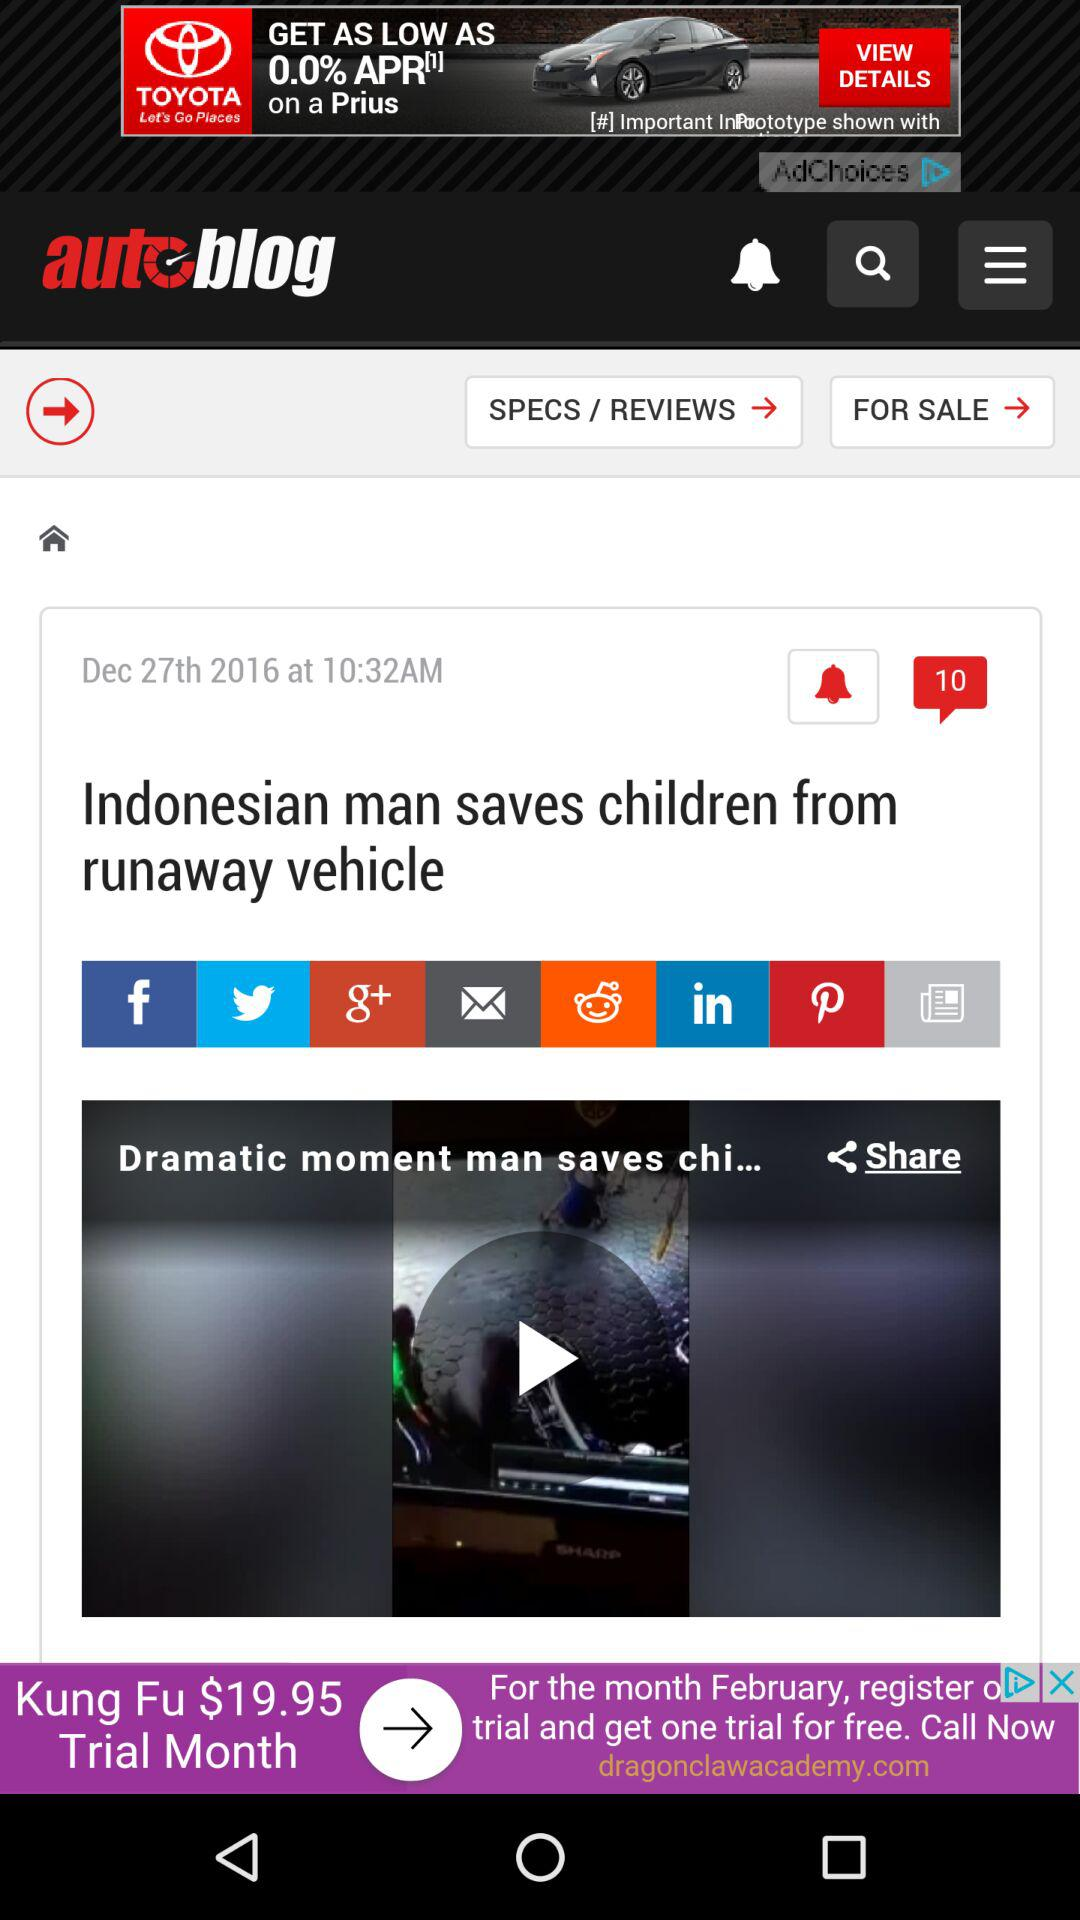Can we share video?
When the provided information is insufficient, respond with <no answer>. <no answer> 